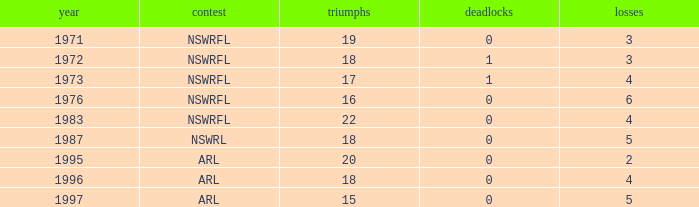What average Wins has Losses 2, and Draws less than 0? None. 